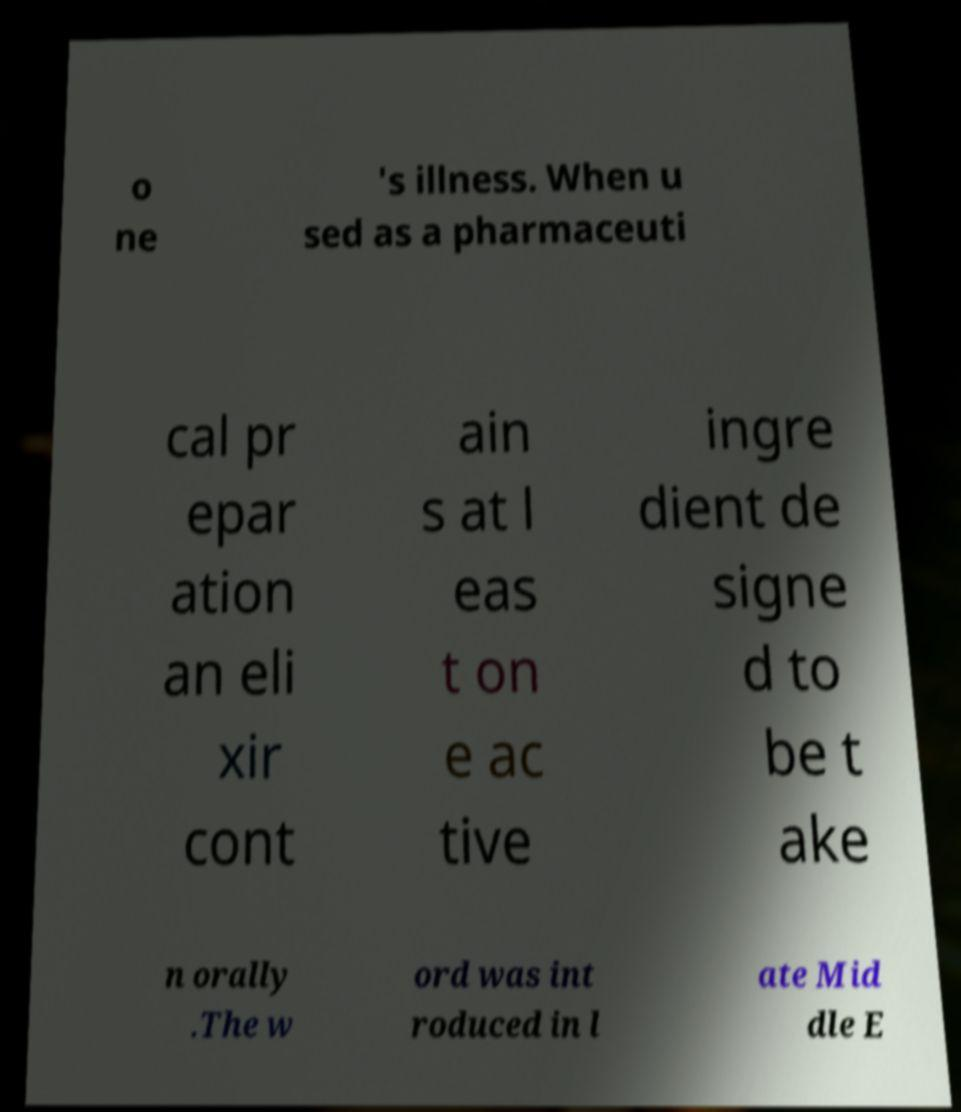Can you accurately transcribe the text from the provided image for me? o ne 's illness. When u sed as a pharmaceuti cal pr epar ation an eli xir cont ain s at l eas t on e ac tive ingre dient de signe d to be t ake n orally .The w ord was int roduced in l ate Mid dle E 